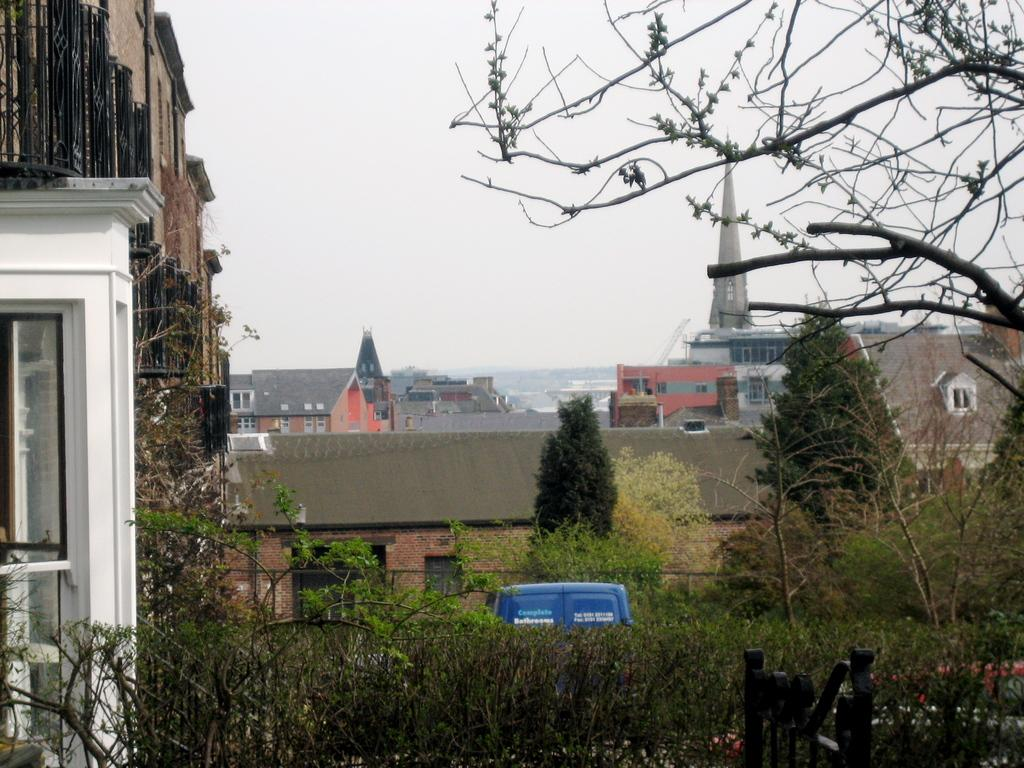What types of objects are on the ground in the image? There are vehicles on the ground in the image. What kind of barrier is present in the image? There is a fence in the image. What structures can be seen in the image? There are buildings in the image. What type of vegetation is present in the image? There are trees in the image. What is visible in the background of the image? The sky is visible in the background of the image. Can you tell me the reason why the snake is slithering through the fence in the image? There is no snake present in the image; it only features vehicles, a fence, buildings, trees, and the sky. 